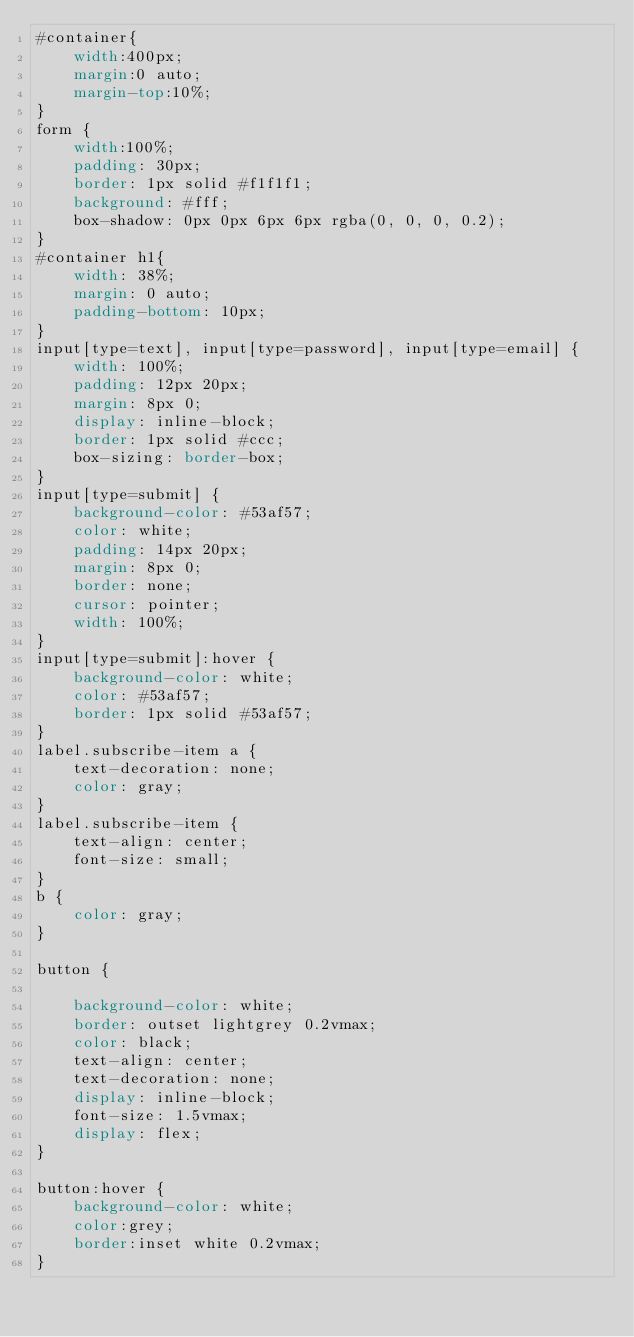<code> <loc_0><loc_0><loc_500><loc_500><_CSS_>#container{
    width:400px;
    margin:0 auto;
    margin-top:10%;
}
form {
    width:100%;
    padding: 30px;
    border: 1px solid #f1f1f1;
    background: #fff;
    box-shadow: 0px 0px 6px 6px rgba(0, 0, 0, 0.2);
}
#container h1{
    width: 38%;
    margin: 0 auto;
    padding-bottom: 10px;
}
input[type=text], input[type=password], input[type=email] {
    width: 100%;
    padding: 12px 20px;
    margin: 8px 0;
    display: inline-block;
    border: 1px solid #ccc;
    box-sizing: border-box;
}
input[type=submit] {
    background-color: #53af57;
    color: white;
    padding: 14px 20px;
    margin: 8px 0;
    border: none;
    cursor: pointer;
    width: 100%;
}
input[type=submit]:hover {
    background-color: white;
    color: #53af57;
    border: 1px solid #53af57;
}
label.subscribe-item a {
    text-decoration: none;
    color: gray;
}
label.subscribe-item {
    text-align: center;
    font-size: small;
}
b {
    color: gray;
}

button {

    background-color: white;
    border: outset lightgrey 0.2vmax;
    color: black;
    text-align: center;
    text-decoration: none;
    display: inline-block;
    font-size: 1.5vmax;
    display: flex;
}

button:hover {
    background-color: white;
    color:grey;
    border:inset white 0.2vmax;
}

</code> 